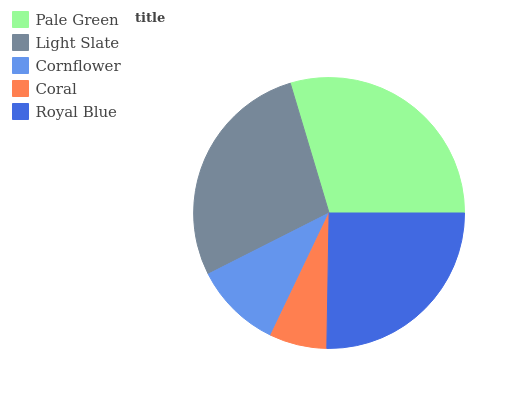Is Coral the minimum?
Answer yes or no. Yes. Is Pale Green the maximum?
Answer yes or no. Yes. Is Light Slate the minimum?
Answer yes or no. No. Is Light Slate the maximum?
Answer yes or no. No. Is Pale Green greater than Light Slate?
Answer yes or no. Yes. Is Light Slate less than Pale Green?
Answer yes or no. Yes. Is Light Slate greater than Pale Green?
Answer yes or no. No. Is Pale Green less than Light Slate?
Answer yes or no. No. Is Royal Blue the high median?
Answer yes or no. Yes. Is Royal Blue the low median?
Answer yes or no. Yes. Is Light Slate the high median?
Answer yes or no. No. Is Coral the low median?
Answer yes or no. No. 